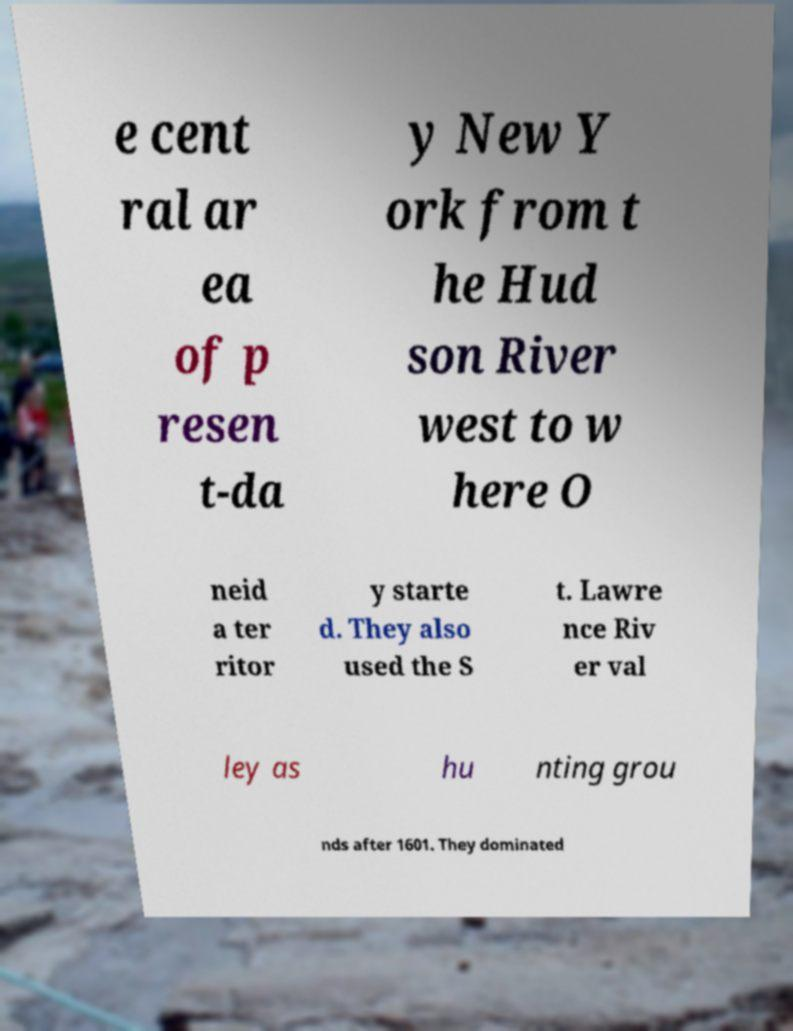Could you extract and type out the text from this image? e cent ral ar ea of p resen t-da y New Y ork from t he Hud son River west to w here O neid a ter ritor y starte d. They also used the S t. Lawre nce Riv er val ley as hu nting grou nds after 1601. They dominated 